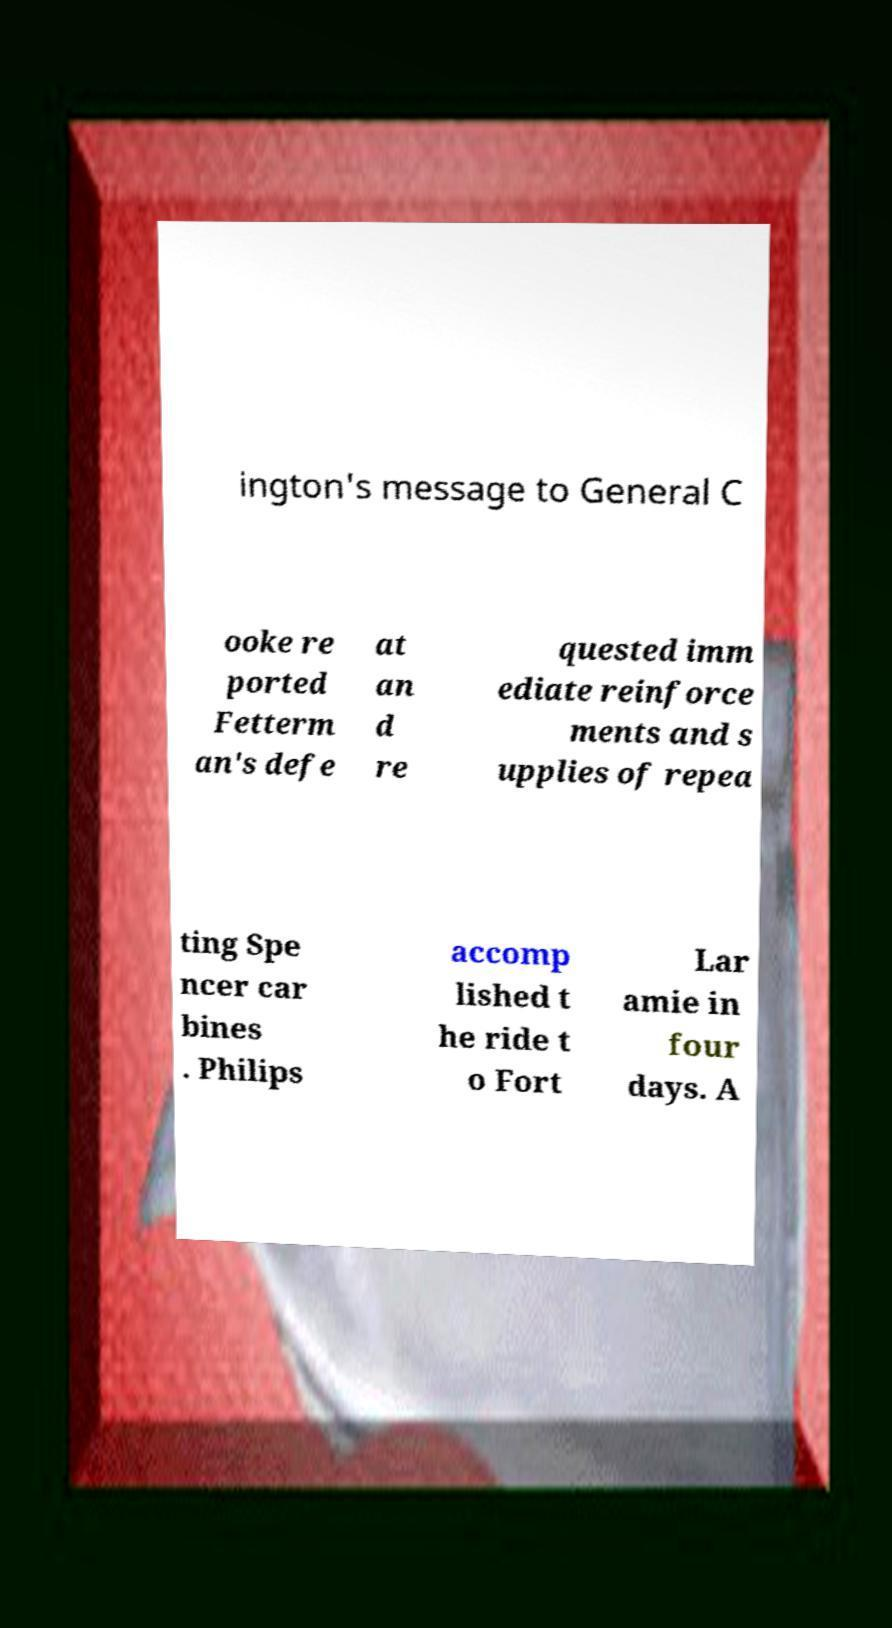Could you assist in decoding the text presented in this image and type it out clearly? ington's message to General C ooke re ported Fetterm an's defe at an d re quested imm ediate reinforce ments and s upplies of repea ting Spe ncer car bines . Philips accomp lished t he ride t o Fort Lar amie in four days. A 